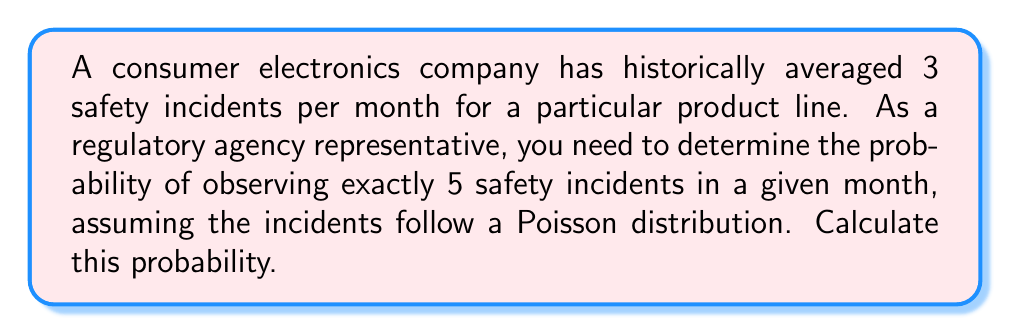Provide a solution to this math problem. To solve this problem, we'll use the Poisson distribution formula:

$$P(X = k) = \frac{e^{-\lambda} \lambda^k}{k!}$$

Where:
$\lambda$ = average rate of occurrence
$k$ = number of occurrences we're interested in
$e$ = Euler's number (approximately 2.71828)

Given:
$\lambda = 3$ (average 3 incidents per month)
$k = 5$ (we're interested in exactly 5 incidents)

Steps:
1) Plug the values into the formula:

   $$P(X = 5) = \frac{e^{-3} 3^5}{5!}$$

2) Calculate $3^5 = 243$

3) Calculate $5! = 5 \times 4 \times 3 \times 2 \times 1 = 120$

4) Calculate $e^{-3} \approx 0.0497871$

5) Put it all together:

   $$P(X = 5) = \frac{0.0497871 \times 243}{120} \approx 0.1008$$

6) Convert to a percentage: 0.1008 × 100% ≈ 10.08%
Answer: 10.08% 